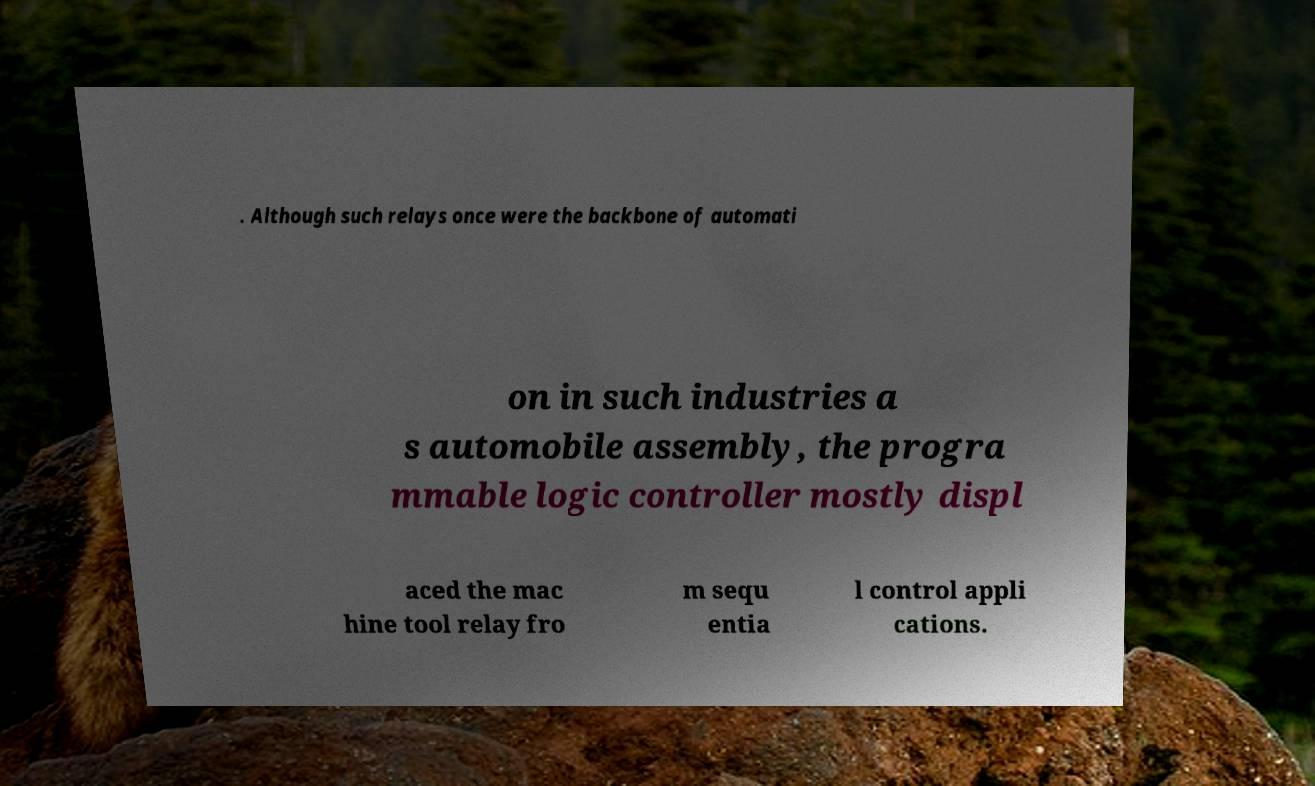Please identify and transcribe the text found in this image. . Although such relays once were the backbone of automati on in such industries a s automobile assembly, the progra mmable logic controller mostly displ aced the mac hine tool relay fro m sequ entia l control appli cations. 